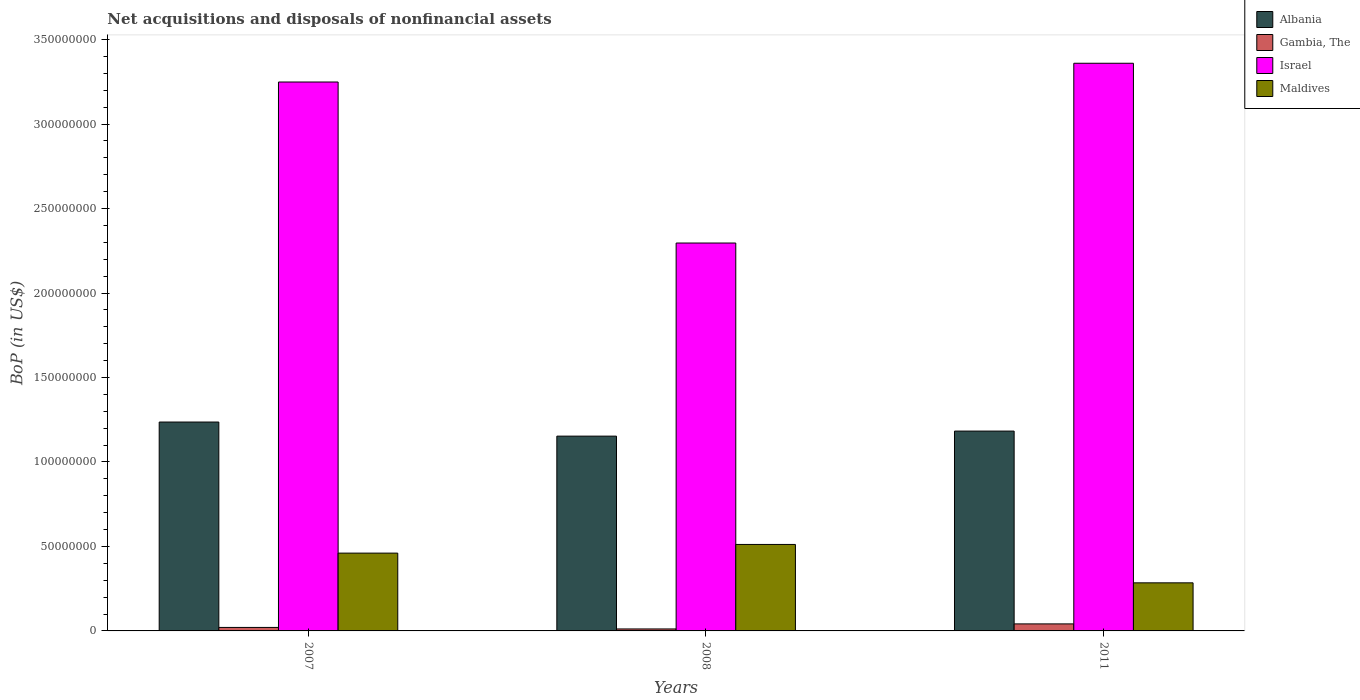How many different coloured bars are there?
Provide a short and direct response. 4. Are the number of bars per tick equal to the number of legend labels?
Make the answer very short. Yes. Are the number of bars on each tick of the X-axis equal?
Your answer should be very brief. Yes. How many bars are there on the 1st tick from the left?
Your answer should be very brief. 4. In how many cases, is the number of bars for a given year not equal to the number of legend labels?
Keep it short and to the point. 0. What is the Balance of Payments in Israel in 2008?
Your answer should be very brief. 2.30e+08. Across all years, what is the maximum Balance of Payments in Albania?
Your response must be concise. 1.24e+08. Across all years, what is the minimum Balance of Payments in Israel?
Provide a succinct answer. 2.30e+08. What is the total Balance of Payments in Maldives in the graph?
Keep it short and to the point. 1.26e+08. What is the difference between the Balance of Payments in Gambia, The in 2007 and that in 2011?
Make the answer very short. -2.09e+06. What is the difference between the Balance of Payments in Maldives in 2008 and the Balance of Payments in Israel in 2007?
Make the answer very short. -2.74e+08. What is the average Balance of Payments in Gambia, The per year?
Give a very brief answer. 2.46e+06. In the year 2011, what is the difference between the Balance of Payments in Maldives and Balance of Payments in Gambia, The?
Provide a succinct answer. 2.43e+07. In how many years, is the Balance of Payments in Maldives greater than 10000000 US$?
Offer a terse response. 3. What is the ratio of the Balance of Payments in Gambia, The in 2008 to that in 2011?
Keep it short and to the point. 0.28. Is the difference between the Balance of Payments in Maldives in 2007 and 2011 greater than the difference between the Balance of Payments in Gambia, The in 2007 and 2011?
Provide a succinct answer. Yes. What is the difference between the highest and the second highest Balance of Payments in Israel?
Keep it short and to the point. 1.11e+07. What is the difference between the highest and the lowest Balance of Payments in Maldives?
Provide a short and direct response. 2.27e+07. Is it the case that in every year, the sum of the Balance of Payments in Albania and Balance of Payments in Maldives is greater than the sum of Balance of Payments in Gambia, The and Balance of Payments in Israel?
Keep it short and to the point. Yes. What does the 3rd bar from the left in 2008 represents?
Offer a terse response. Israel. What does the 4th bar from the right in 2007 represents?
Keep it short and to the point. Albania. How many bars are there?
Keep it short and to the point. 12. How many years are there in the graph?
Offer a terse response. 3. What is the difference between two consecutive major ticks on the Y-axis?
Ensure brevity in your answer.  5.00e+07. Are the values on the major ticks of Y-axis written in scientific E-notation?
Offer a terse response. No. Does the graph contain grids?
Keep it short and to the point. No. What is the title of the graph?
Make the answer very short. Net acquisitions and disposals of nonfinancial assets. What is the label or title of the X-axis?
Keep it short and to the point. Years. What is the label or title of the Y-axis?
Your answer should be compact. BoP (in US$). What is the BoP (in US$) in Albania in 2007?
Offer a terse response. 1.24e+08. What is the BoP (in US$) of Gambia, The in 2007?
Your response must be concise. 2.07e+06. What is the BoP (in US$) of Israel in 2007?
Give a very brief answer. 3.25e+08. What is the BoP (in US$) in Maldives in 2007?
Ensure brevity in your answer.  4.61e+07. What is the BoP (in US$) in Albania in 2008?
Your answer should be very brief. 1.15e+08. What is the BoP (in US$) of Gambia, The in 2008?
Make the answer very short. 1.17e+06. What is the BoP (in US$) of Israel in 2008?
Provide a short and direct response. 2.30e+08. What is the BoP (in US$) of Maldives in 2008?
Offer a terse response. 5.12e+07. What is the BoP (in US$) of Albania in 2011?
Ensure brevity in your answer.  1.18e+08. What is the BoP (in US$) in Gambia, The in 2011?
Keep it short and to the point. 4.15e+06. What is the BoP (in US$) in Israel in 2011?
Keep it short and to the point. 3.36e+08. What is the BoP (in US$) of Maldives in 2011?
Your response must be concise. 2.85e+07. Across all years, what is the maximum BoP (in US$) in Albania?
Provide a succinct answer. 1.24e+08. Across all years, what is the maximum BoP (in US$) of Gambia, The?
Ensure brevity in your answer.  4.15e+06. Across all years, what is the maximum BoP (in US$) of Israel?
Provide a succinct answer. 3.36e+08. Across all years, what is the maximum BoP (in US$) in Maldives?
Make the answer very short. 5.12e+07. Across all years, what is the minimum BoP (in US$) in Albania?
Make the answer very short. 1.15e+08. Across all years, what is the minimum BoP (in US$) in Gambia, The?
Provide a succinct answer. 1.17e+06. Across all years, what is the minimum BoP (in US$) in Israel?
Ensure brevity in your answer.  2.30e+08. Across all years, what is the minimum BoP (in US$) in Maldives?
Ensure brevity in your answer.  2.85e+07. What is the total BoP (in US$) in Albania in the graph?
Your answer should be compact. 3.57e+08. What is the total BoP (in US$) of Gambia, The in the graph?
Ensure brevity in your answer.  7.39e+06. What is the total BoP (in US$) in Israel in the graph?
Provide a succinct answer. 8.90e+08. What is the total BoP (in US$) in Maldives in the graph?
Offer a terse response. 1.26e+08. What is the difference between the BoP (in US$) of Albania in 2007 and that in 2008?
Provide a succinct answer. 8.34e+06. What is the difference between the BoP (in US$) of Gambia, The in 2007 and that in 2008?
Your response must be concise. 8.96e+05. What is the difference between the BoP (in US$) of Israel in 2007 and that in 2008?
Provide a short and direct response. 9.53e+07. What is the difference between the BoP (in US$) of Maldives in 2007 and that in 2008?
Provide a succinct answer. -5.13e+06. What is the difference between the BoP (in US$) in Albania in 2007 and that in 2011?
Provide a succinct answer. 5.35e+06. What is the difference between the BoP (in US$) of Gambia, The in 2007 and that in 2011?
Make the answer very short. -2.09e+06. What is the difference between the BoP (in US$) in Israel in 2007 and that in 2011?
Your response must be concise. -1.11e+07. What is the difference between the BoP (in US$) in Maldives in 2007 and that in 2011?
Provide a short and direct response. 1.76e+07. What is the difference between the BoP (in US$) of Albania in 2008 and that in 2011?
Your response must be concise. -2.99e+06. What is the difference between the BoP (in US$) of Gambia, The in 2008 and that in 2011?
Offer a very short reply. -2.98e+06. What is the difference between the BoP (in US$) of Israel in 2008 and that in 2011?
Your answer should be compact. -1.06e+08. What is the difference between the BoP (in US$) in Maldives in 2008 and that in 2011?
Your response must be concise. 2.27e+07. What is the difference between the BoP (in US$) of Albania in 2007 and the BoP (in US$) of Gambia, The in 2008?
Give a very brief answer. 1.22e+08. What is the difference between the BoP (in US$) of Albania in 2007 and the BoP (in US$) of Israel in 2008?
Provide a succinct answer. -1.06e+08. What is the difference between the BoP (in US$) of Albania in 2007 and the BoP (in US$) of Maldives in 2008?
Ensure brevity in your answer.  7.25e+07. What is the difference between the BoP (in US$) in Gambia, The in 2007 and the BoP (in US$) in Israel in 2008?
Your answer should be very brief. -2.28e+08. What is the difference between the BoP (in US$) in Gambia, The in 2007 and the BoP (in US$) in Maldives in 2008?
Provide a succinct answer. -4.91e+07. What is the difference between the BoP (in US$) of Israel in 2007 and the BoP (in US$) of Maldives in 2008?
Your answer should be very brief. 2.74e+08. What is the difference between the BoP (in US$) in Albania in 2007 and the BoP (in US$) in Gambia, The in 2011?
Your response must be concise. 1.19e+08. What is the difference between the BoP (in US$) in Albania in 2007 and the BoP (in US$) in Israel in 2011?
Make the answer very short. -2.12e+08. What is the difference between the BoP (in US$) of Albania in 2007 and the BoP (in US$) of Maldives in 2011?
Provide a short and direct response. 9.52e+07. What is the difference between the BoP (in US$) of Gambia, The in 2007 and the BoP (in US$) of Israel in 2011?
Offer a very short reply. -3.34e+08. What is the difference between the BoP (in US$) of Gambia, The in 2007 and the BoP (in US$) of Maldives in 2011?
Offer a very short reply. -2.64e+07. What is the difference between the BoP (in US$) of Israel in 2007 and the BoP (in US$) of Maldives in 2011?
Your response must be concise. 2.96e+08. What is the difference between the BoP (in US$) of Albania in 2008 and the BoP (in US$) of Gambia, The in 2011?
Your answer should be very brief. 1.11e+08. What is the difference between the BoP (in US$) of Albania in 2008 and the BoP (in US$) of Israel in 2011?
Provide a short and direct response. -2.21e+08. What is the difference between the BoP (in US$) of Albania in 2008 and the BoP (in US$) of Maldives in 2011?
Your answer should be very brief. 8.68e+07. What is the difference between the BoP (in US$) of Gambia, The in 2008 and the BoP (in US$) of Israel in 2011?
Your response must be concise. -3.35e+08. What is the difference between the BoP (in US$) of Gambia, The in 2008 and the BoP (in US$) of Maldives in 2011?
Offer a terse response. -2.73e+07. What is the difference between the BoP (in US$) of Israel in 2008 and the BoP (in US$) of Maldives in 2011?
Your response must be concise. 2.01e+08. What is the average BoP (in US$) in Albania per year?
Provide a short and direct response. 1.19e+08. What is the average BoP (in US$) of Gambia, The per year?
Make the answer very short. 2.46e+06. What is the average BoP (in US$) of Israel per year?
Your response must be concise. 2.97e+08. What is the average BoP (in US$) in Maldives per year?
Offer a very short reply. 4.19e+07. In the year 2007, what is the difference between the BoP (in US$) of Albania and BoP (in US$) of Gambia, The?
Keep it short and to the point. 1.22e+08. In the year 2007, what is the difference between the BoP (in US$) of Albania and BoP (in US$) of Israel?
Make the answer very short. -2.01e+08. In the year 2007, what is the difference between the BoP (in US$) of Albania and BoP (in US$) of Maldives?
Give a very brief answer. 7.76e+07. In the year 2007, what is the difference between the BoP (in US$) of Gambia, The and BoP (in US$) of Israel?
Make the answer very short. -3.23e+08. In the year 2007, what is the difference between the BoP (in US$) in Gambia, The and BoP (in US$) in Maldives?
Your answer should be very brief. -4.40e+07. In the year 2007, what is the difference between the BoP (in US$) in Israel and BoP (in US$) in Maldives?
Offer a very short reply. 2.79e+08. In the year 2008, what is the difference between the BoP (in US$) in Albania and BoP (in US$) in Gambia, The?
Provide a short and direct response. 1.14e+08. In the year 2008, what is the difference between the BoP (in US$) in Albania and BoP (in US$) in Israel?
Give a very brief answer. -1.14e+08. In the year 2008, what is the difference between the BoP (in US$) of Albania and BoP (in US$) of Maldives?
Ensure brevity in your answer.  6.41e+07. In the year 2008, what is the difference between the BoP (in US$) of Gambia, The and BoP (in US$) of Israel?
Your response must be concise. -2.28e+08. In the year 2008, what is the difference between the BoP (in US$) of Gambia, The and BoP (in US$) of Maldives?
Make the answer very short. -5.00e+07. In the year 2008, what is the difference between the BoP (in US$) in Israel and BoP (in US$) in Maldives?
Give a very brief answer. 1.78e+08. In the year 2011, what is the difference between the BoP (in US$) in Albania and BoP (in US$) in Gambia, The?
Offer a terse response. 1.14e+08. In the year 2011, what is the difference between the BoP (in US$) of Albania and BoP (in US$) of Israel?
Offer a very short reply. -2.18e+08. In the year 2011, what is the difference between the BoP (in US$) of Albania and BoP (in US$) of Maldives?
Make the answer very short. 8.98e+07. In the year 2011, what is the difference between the BoP (in US$) in Gambia, The and BoP (in US$) in Israel?
Your response must be concise. -3.32e+08. In the year 2011, what is the difference between the BoP (in US$) of Gambia, The and BoP (in US$) of Maldives?
Your answer should be very brief. -2.43e+07. In the year 2011, what is the difference between the BoP (in US$) of Israel and BoP (in US$) of Maldives?
Your answer should be very brief. 3.08e+08. What is the ratio of the BoP (in US$) of Albania in 2007 to that in 2008?
Your answer should be compact. 1.07. What is the ratio of the BoP (in US$) in Gambia, The in 2007 to that in 2008?
Ensure brevity in your answer.  1.76. What is the ratio of the BoP (in US$) of Israel in 2007 to that in 2008?
Provide a short and direct response. 1.42. What is the ratio of the BoP (in US$) in Maldives in 2007 to that in 2008?
Provide a short and direct response. 0.9. What is the ratio of the BoP (in US$) in Albania in 2007 to that in 2011?
Ensure brevity in your answer.  1.05. What is the ratio of the BoP (in US$) of Gambia, The in 2007 to that in 2011?
Offer a terse response. 0.5. What is the ratio of the BoP (in US$) in Israel in 2007 to that in 2011?
Your answer should be compact. 0.97. What is the ratio of the BoP (in US$) of Maldives in 2007 to that in 2011?
Offer a terse response. 1.62. What is the ratio of the BoP (in US$) in Albania in 2008 to that in 2011?
Provide a succinct answer. 0.97. What is the ratio of the BoP (in US$) in Gambia, The in 2008 to that in 2011?
Offer a terse response. 0.28. What is the ratio of the BoP (in US$) of Israel in 2008 to that in 2011?
Your response must be concise. 0.68. What is the ratio of the BoP (in US$) of Maldives in 2008 to that in 2011?
Offer a terse response. 1.8. What is the difference between the highest and the second highest BoP (in US$) in Albania?
Provide a succinct answer. 5.35e+06. What is the difference between the highest and the second highest BoP (in US$) of Gambia, The?
Provide a succinct answer. 2.09e+06. What is the difference between the highest and the second highest BoP (in US$) in Israel?
Your response must be concise. 1.11e+07. What is the difference between the highest and the second highest BoP (in US$) of Maldives?
Offer a very short reply. 5.13e+06. What is the difference between the highest and the lowest BoP (in US$) of Albania?
Give a very brief answer. 8.34e+06. What is the difference between the highest and the lowest BoP (in US$) of Gambia, The?
Keep it short and to the point. 2.98e+06. What is the difference between the highest and the lowest BoP (in US$) of Israel?
Ensure brevity in your answer.  1.06e+08. What is the difference between the highest and the lowest BoP (in US$) in Maldives?
Ensure brevity in your answer.  2.27e+07. 